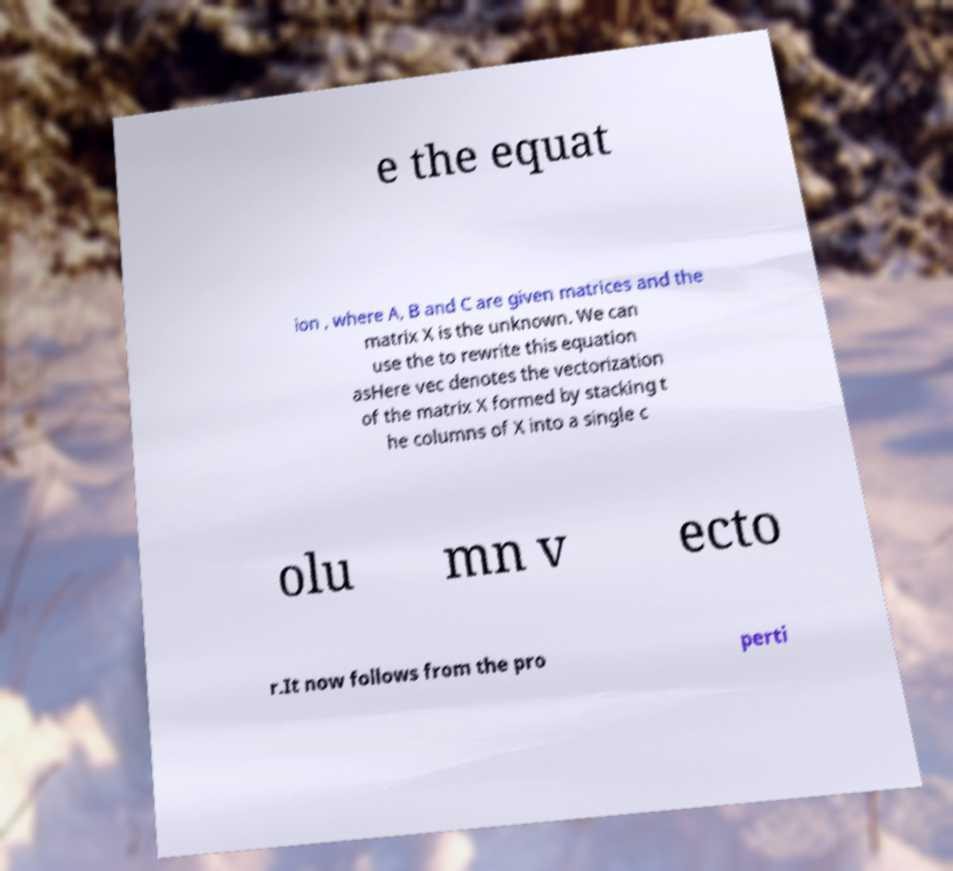Could you extract and type out the text from this image? e the equat ion , where A, B and C are given matrices and the matrix X is the unknown. We can use the to rewrite this equation asHere vec denotes the vectorization of the matrix X formed by stacking t he columns of X into a single c olu mn v ecto r.It now follows from the pro perti 